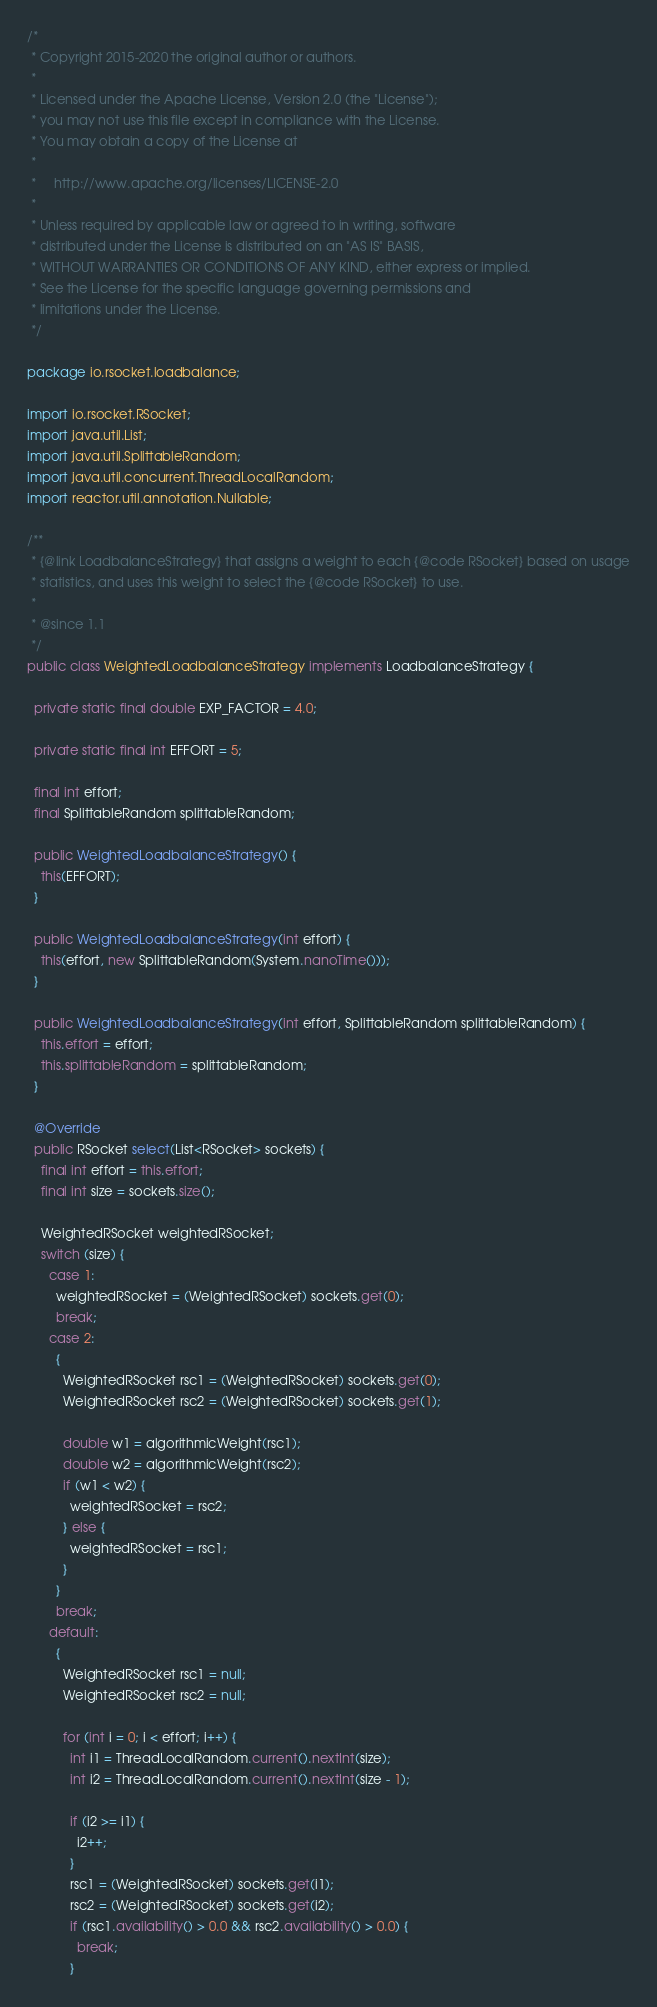Convert code to text. <code><loc_0><loc_0><loc_500><loc_500><_Java_>/*
 * Copyright 2015-2020 the original author or authors.
 *
 * Licensed under the Apache License, Version 2.0 (the "License");
 * you may not use this file except in compliance with the License.
 * You may obtain a copy of the License at
 *
 *     http://www.apache.org/licenses/LICENSE-2.0
 *
 * Unless required by applicable law or agreed to in writing, software
 * distributed under the License is distributed on an "AS IS" BASIS,
 * WITHOUT WARRANTIES OR CONDITIONS OF ANY KIND, either express or implied.
 * See the License for the specific language governing permissions and
 * limitations under the License.
 */

package io.rsocket.loadbalance;

import io.rsocket.RSocket;
import java.util.List;
import java.util.SplittableRandom;
import java.util.concurrent.ThreadLocalRandom;
import reactor.util.annotation.Nullable;

/**
 * {@link LoadbalanceStrategy} that assigns a weight to each {@code RSocket} based on usage
 * statistics, and uses this weight to select the {@code RSocket} to use.
 *
 * @since 1.1
 */
public class WeightedLoadbalanceStrategy implements LoadbalanceStrategy {

  private static final double EXP_FACTOR = 4.0;

  private static final int EFFORT = 5;

  final int effort;
  final SplittableRandom splittableRandom;

  public WeightedLoadbalanceStrategy() {
    this(EFFORT);
  }

  public WeightedLoadbalanceStrategy(int effort) {
    this(effort, new SplittableRandom(System.nanoTime()));
  }

  public WeightedLoadbalanceStrategy(int effort, SplittableRandom splittableRandom) {
    this.effort = effort;
    this.splittableRandom = splittableRandom;
  }

  @Override
  public RSocket select(List<RSocket> sockets) {
    final int effort = this.effort;
    final int size = sockets.size();

    WeightedRSocket weightedRSocket;
    switch (size) {
      case 1:
        weightedRSocket = (WeightedRSocket) sockets.get(0);
        break;
      case 2:
        {
          WeightedRSocket rsc1 = (WeightedRSocket) sockets.get(0);
          WeightedRSocket rsc2 = (WeightedRSocket) sockets.get(1);

          double w1 = algorithmicWeight(rsc1);
          double w2 = algorithmicWeight(rsc2);
          if (w1 < w2) {
            weightedRSocket = rsc2;
          } else {
            weightedRSocket = rsc1;
          }
        }
        break;
      default:
        {
          WeightedRSocket rsc1 = null;
          WeightedRSocket rsc2 = null;

          for (int i = 0; i < effort; i++) {
            int i1 = ThreadLocalRandom.current().nextInt(size);
            int i2 = ThreadLocalRandom.current().nextInt(size - 1);

            if (i2 >= i1) {
              i2++;
            }
            rsc1 = (WeightedRSocket) sockets.get(i1);
            rsc2 = (WeightedRSocket) sockets.get(i2);
            if (rsc1.availability() > 0.0 && rsc2.availability() > 0.0) {
              break;
            }</code> 